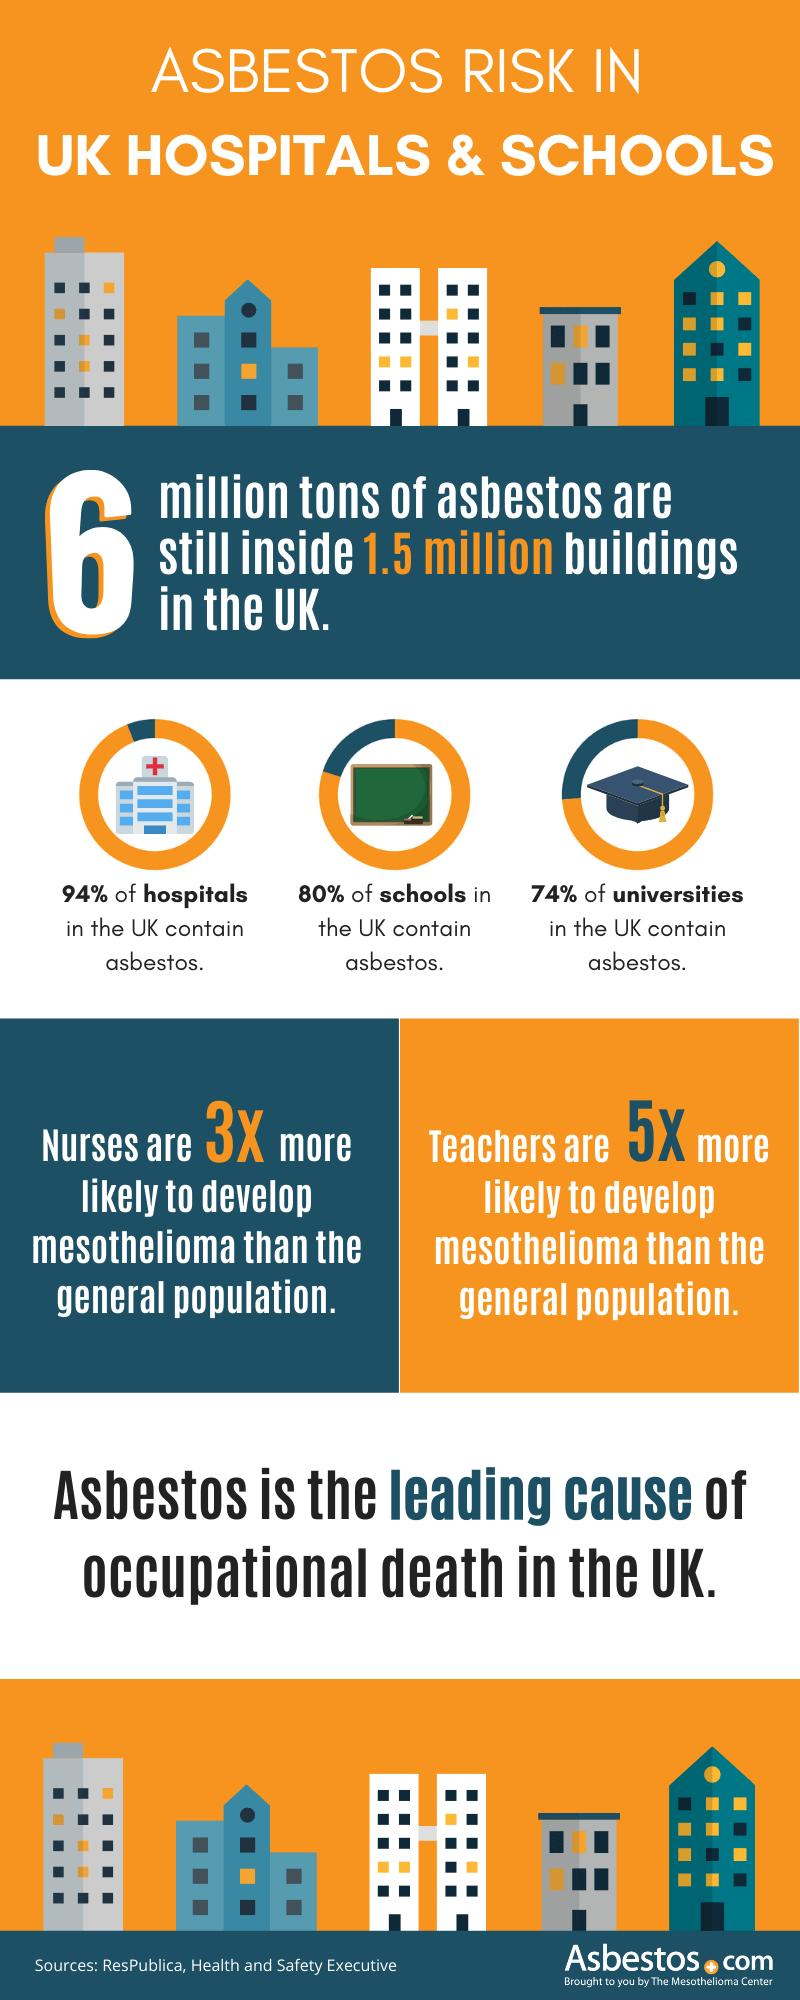Identify some key points in this picture. Only 6% of hospital buildings in the UK do not contain asbestos. According to a recent survey, approximately 20% of school buildings in the UK do not contain asbestos. According to a recent study, only 26% of university buildings in the UK do not contain asbestos. 